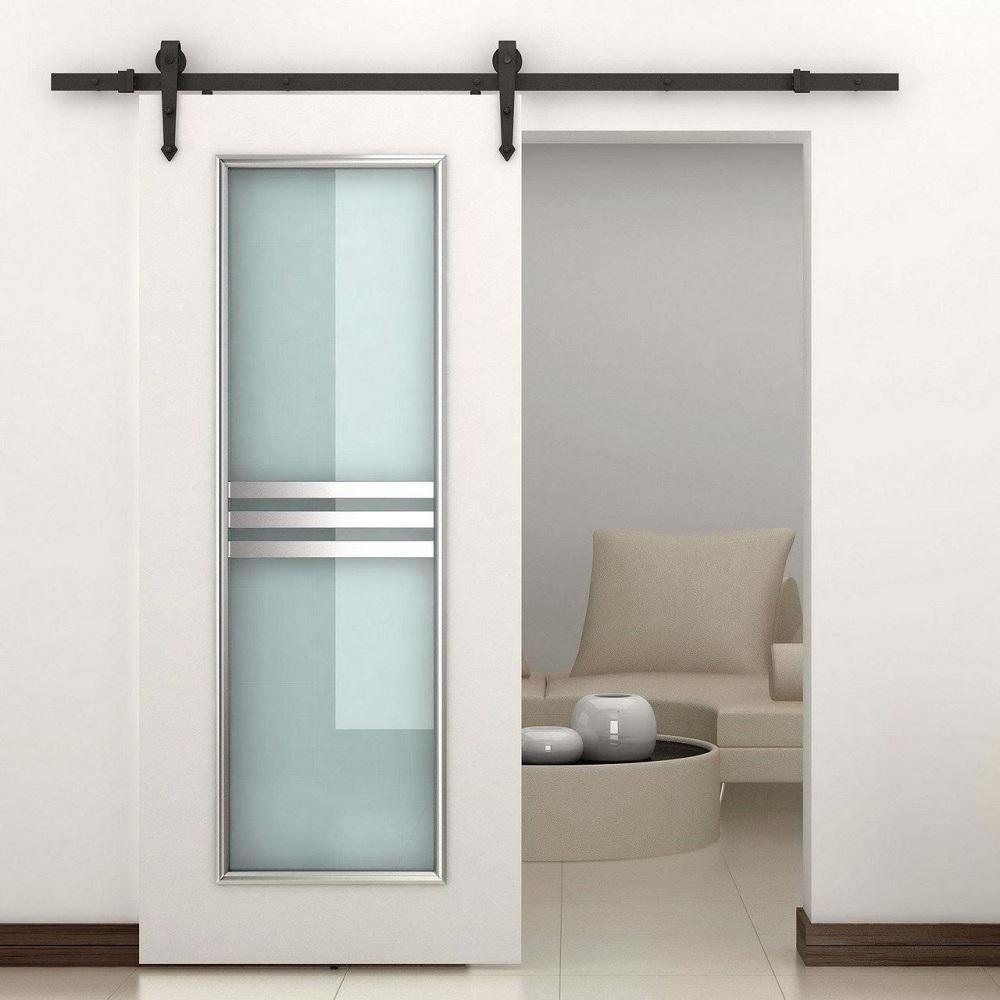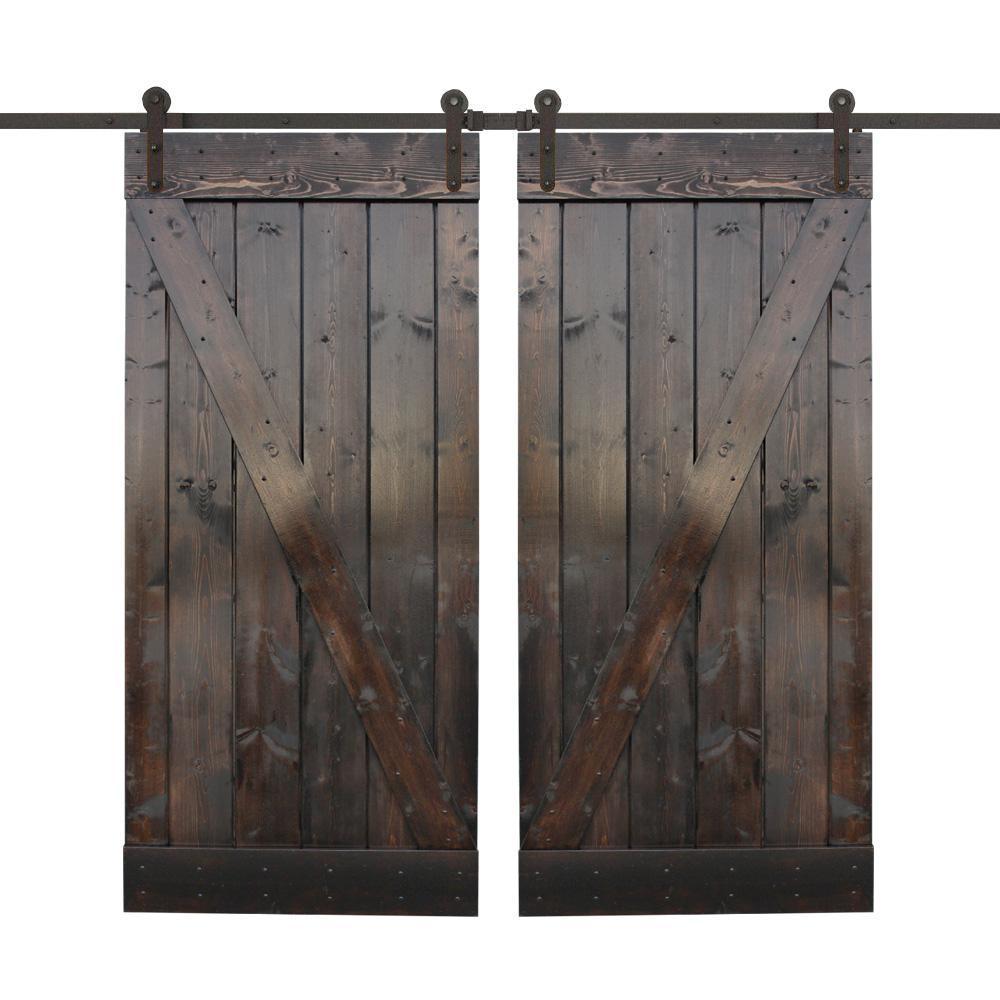The first image is the image on the left, the second image is the image on the right. Given the left and right images, does the statement "There are three hanging doors." hold true? Answer yes or no. Yes. 